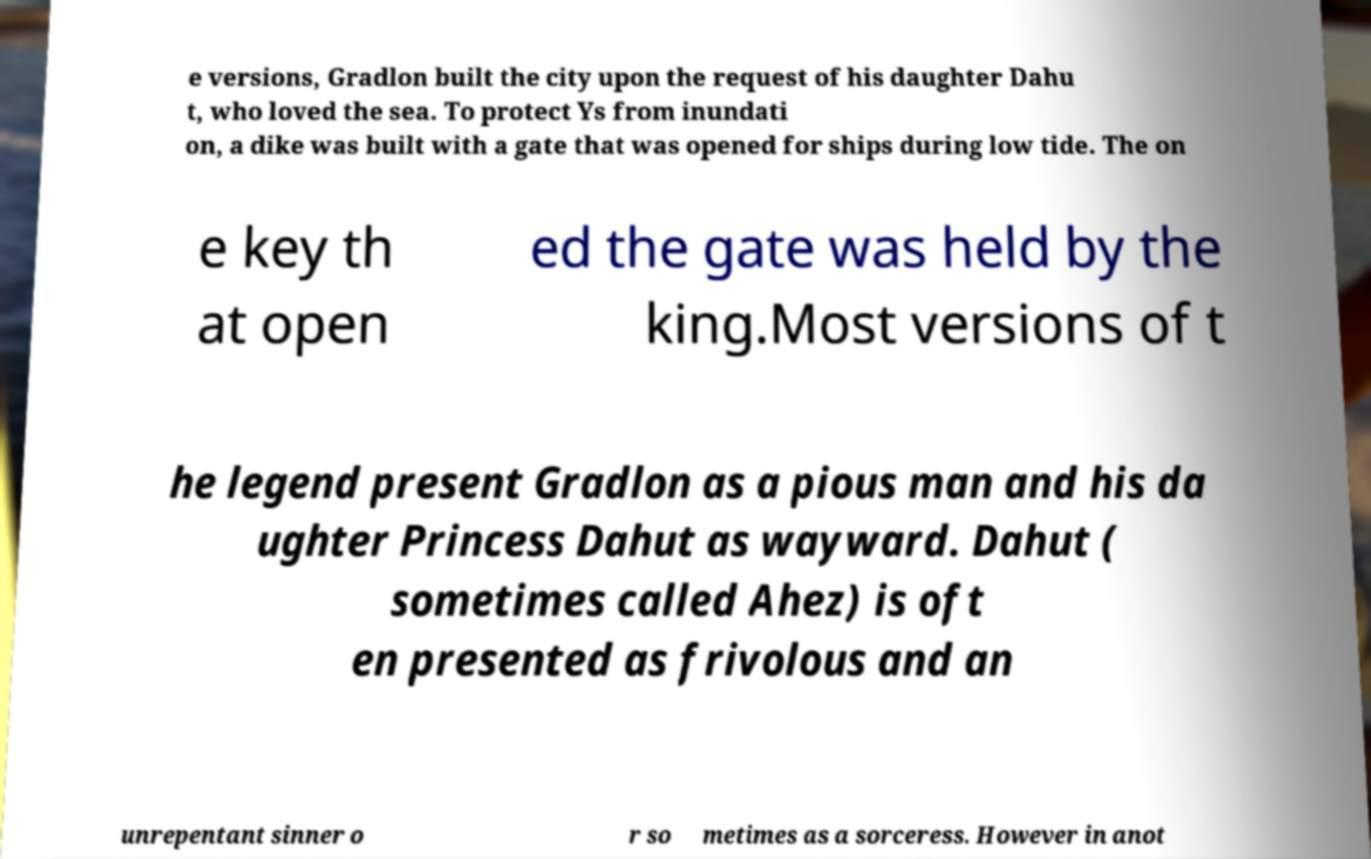Please read and relay the text visible in this image. What does it say? e versions, Gradlon built the city upon the request of his daughter Dahu t, who loved the sea. To protect Ys from inundati on, a dike was built with a gate that was opened for ships during low tide. The on e key th at open ed the gate was held by the king.Most versions of t he legend present Gradlon as a pious man and his da ughter Princess Dahut as wayward. Dahut ( sometimes called Ahez) is oft en presented as frivolous and an unrepentant sinner o r so metimes as a sorceress. However in anot 